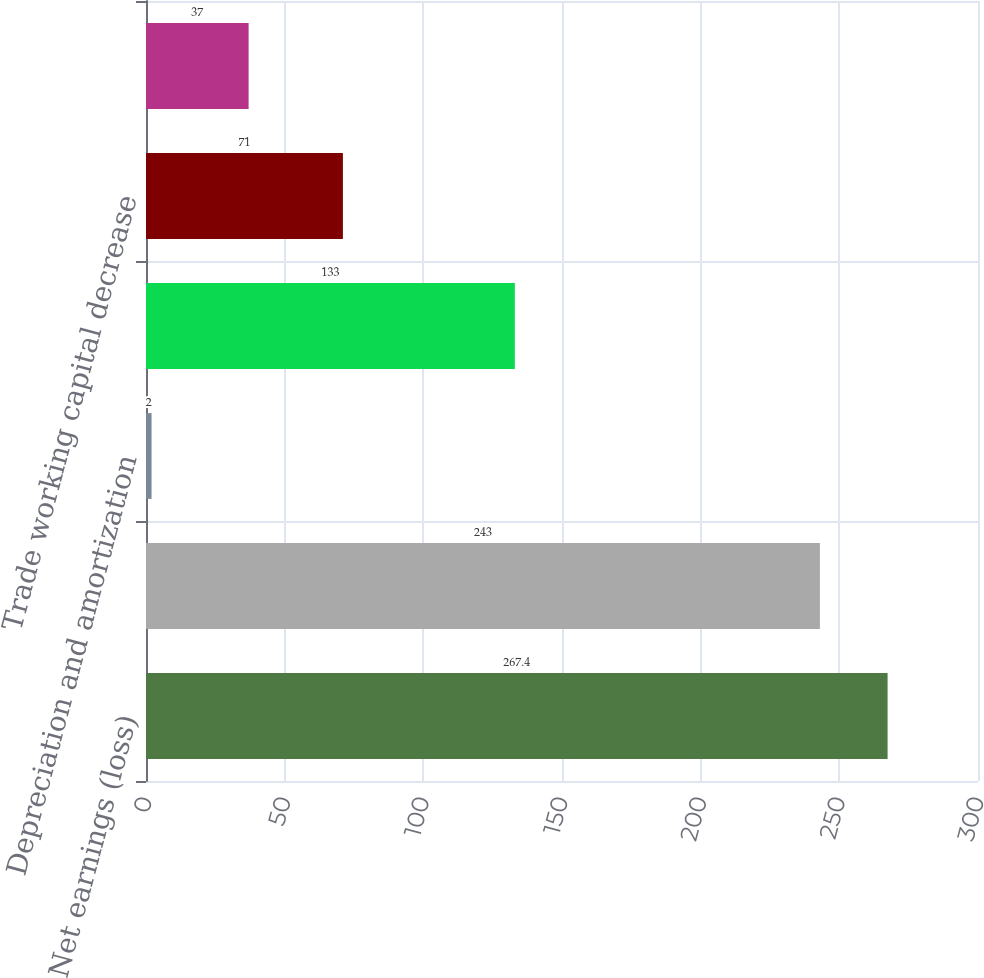Convert chart. <chart><loc_0><loc_0><loc_500><loc_500><bar_chart><fcel>Net earnings (loss)<fcel>Deferred income taxes<fcel>Depreciation and amortization<fcel>Retiree benefit funding less<fcel>Trade working capital decrease<fcel>Net cash provided by (used in)<nl><fcel>267.4<fcel>243<fcel>2<fcel>133<fcel>71<fcel>37<nl></chart> 